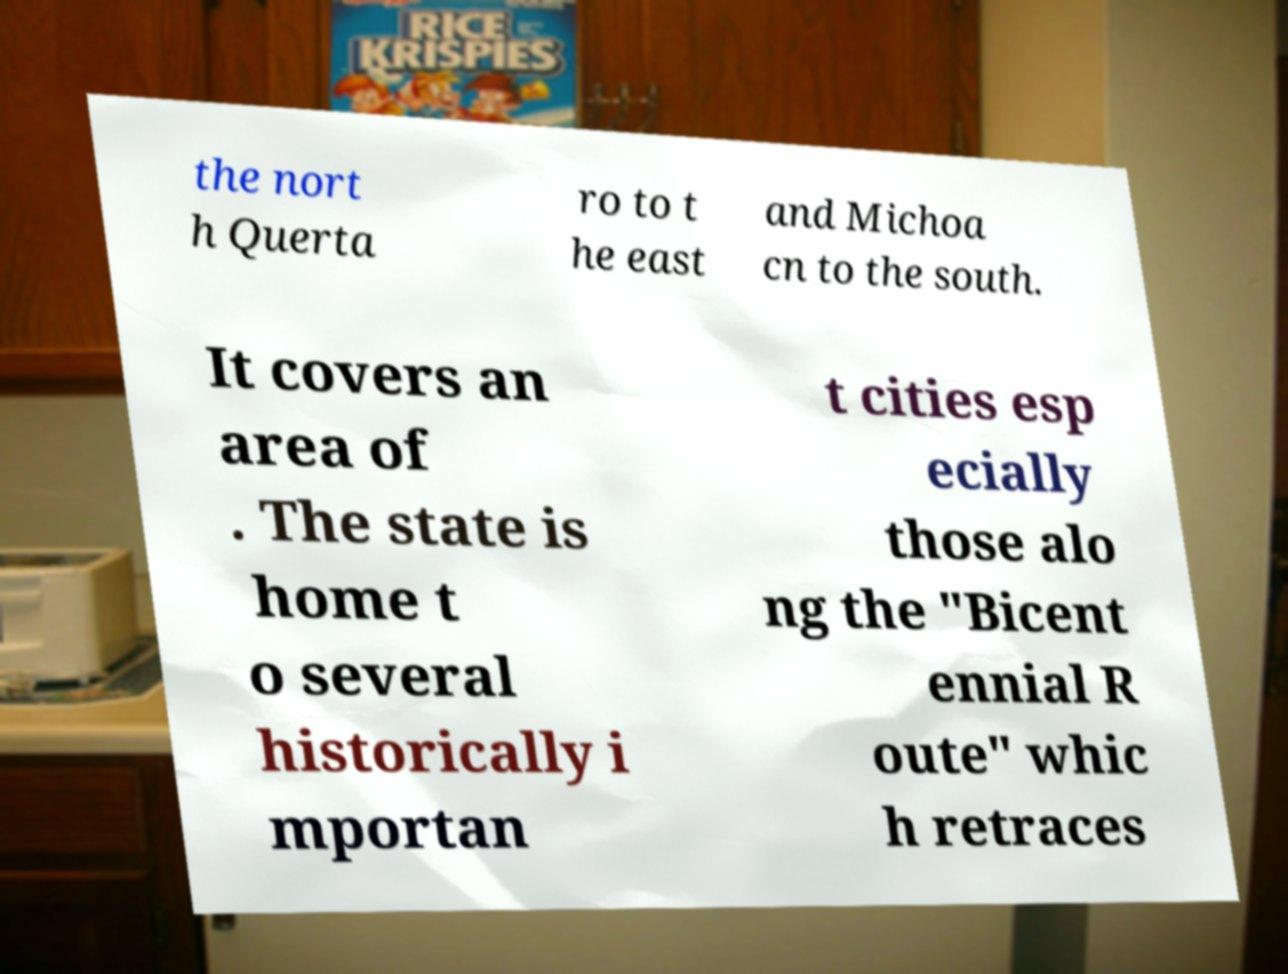For documentation purposes, I need the text within this image transcribed. Could you provide that? the nort h Querta ro to t he east and Michoa cn to the south. It covers an area of . The state is home t o several historically i mportan t cities esp ecially those alo ng the "Bicent ennial R oute" whic h retraces 